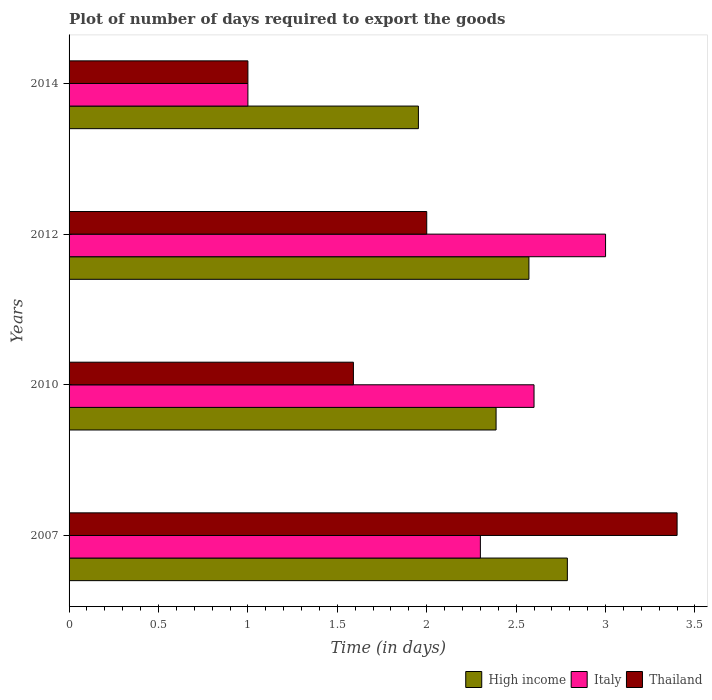How many different coloured bars are there?
Make the answer very short. 3. How many groups of bars are there?
Ensure brevity in your answer.  4. Are the number of bars on each tick of the Y-axis equal?
Provide a short and direct response. Yes. What is the label of the 3rd group of bars from the top?
Give a very brief answer. 2010. In how many cases, is the number of bars for a given year not equal to the number of legend labels?
Your response must be concise. 0. What is the time required to export goods in Thailand in 2014?
Offer a terse response. 1. Across all years, what is the maximum time required to export goods in Thailand?
Give a very brief answer. 3.4. Across all years, what is the minimum time required to export goods in Thailand?
Offer a very short reply. 1. In which year was the time required to export goods in Thailand maximum?
Give a very brief answer. 2007. What is the difference between the time required to export goods in Thailand in 2010 and that in 2012?
Provide a short and direct response. -0.41. What is the difference between the time required to export goods in Italy in 2014 and the time required to export goods in Thailand in 2012?
Your response must be concise. -1. What is the average time required to export goods in High income per year?
Ensure brevity in your answer.  2.42. In the year 2007, what is the difference between the time required to export goods in High income and time required to export goods in Italy?
Offer a terse response. 0.49. What is the ratio of the time required to export goods in Thailand in 2007 to that in 2014?
Give a very brief answer. 3.4. What is the difference between the highest and the second highest time required to export goods in High income?
Ensure brevity in your answer.  0.21. In how many years, is the time required to export goods in Italy greater than the average time required to export goods in Italy taken over all years?
Offer a terse response. 3. Is the sum of the time required to export goods in Italy in 2010 and 2012 greater than the maximum time required to export goods in Thailand across all years?
Ensure brevity in your answer.  Yes. What does the 1st bar from the bottom in 2010 represents?
Provide a short and direct response. High income. Is it the case that in every year, the sum of the time required to export goods in High income and time required to export goods in Italy is greater than the time required to export goods in Thailand?
Ensure brevity in your answer.  Yes. How many bars are there?
Offer a very short reply. 12. What is the difference between two consecutive major ticks on the X-axis?
Make the answer very short. 0.5. Does the graph contain grids?
Provide a short and direct response. No. How many legend labels are there?
Provide a short and direct response. 3. What is the title of the graph?
Your response must be concise. Plot of number of days required to export the goods. What is the label or title of the X-axis?
Provide a succinct answer. Time (in days). What is the Time (in days) in High income in 2007?
Give a very brief answer. 2.79. What is the Time (in days) of Italy in 2007?
Make the answer very short. 2.3. What is the Time (in days) of Thailand in 2007?
Offer a very short reply. 3.4. What is the Time (in days) of High income in 2010?
Your response must be concise. 2.39. What is the Time (in days) of Italy in 2010?
Your answer should be very brief. 2.6. What is the Time (in days) in Thailand in 2010?
Your answer should be compact. 1.59. What is the Time (in days) of High income in 2012?
Offer a very short reply. 2.57. What is the Time (in days) of Italy in 2012?
Provide a succinct answer. 3. What is the Time (in days) in High income in 2014?
Ensure brevity in your answer.  1.95. What is the Time (in days) of Italy in 2014?
Offer a terse response. 1. What is the Time (in days) of Thailand in 2014?
Provide a succinct answer. 1. Across all years, what is the maximum Time (in days) of High income?
Make the answer very short. 2.79. Across all years, what is the maximum Time (in days) of Italy?
Provide a short and direct response. 3. Across all years, what is the minimum Time (in days) of High income?
Offer a terse response. 1.95. What is the total Time (in days) in High income in the graph?
Offer a very short reply. 9.7. What is the total Time (in days) in Thailand in the graph?
Make the answer very short. 7.99. What is the difference between the Time (in days) in High income in 2007 and that in 2010?
Offer a terse response. 0.4. What is the difference between the Time (in days) in Thailand in 2007 and that in 2010?
Offer a terse response. 1.81. What is the difference between the Time (in days) in High income in 2007 and that in 2012?
Offer a terse response. 0.21. What is the difference between the Time (in days) in Italy in 2007 and that in 2012?
Give a very brief answer. -0.7. What is the difference between the Time (in days) in Thailand in 2007 and that in 2012?
Your response must be concise. 1.4. What is the difference between the Time (in days) of High income in 2007 and that in 2014?
Ensure brevity in your answer.  0.83. What is the difference between the Time (in days) in High income in 2010 and that in 2012?
Ensure brevity in your answer.  -0.18. What is the difference between the Time (in days) of Italy in 2010 and that in 2012?
Give a very brief answer. -0.4. What is the difference between the Time (in days) of Thailand in 2010 and that in 2012?
Keep it short and to the point. -0.41. What is the difference between the Time (in days) in High income in 2010 and that in 2014?
Provide a succinct answer. 0.43. What is the difference between the Time (in days) in Italy in 2010 and that in 2014?
Give a very brief answer. 1.6. What is the difference between the Time (in days) of Thailand in 2010 and that in 2014?
Ensure brevity in your answer.  0.59. What is the difference between the Time (in days) in High income in 2012 and that in 2014?
Keep it short and to the point. 0.62. What is the difference between the Time (in days) in Italy in 2012 and that in 2014?
Give a very brief answer. 2. What is the difference between the Time (in days) of Thailand in 2012 and that in 2014?
Your response must be concise. 1. What is the difference between the Time (in days) of High income in 2007 and the Time (in days) of Italy in 2010?
Keep it short and to the point. 0.19. What is the difference between the Time (in days) of High income in 2007 and the Time (in days) of Thailand in 2010?
Offer a very short reply. 1.2. What is the difference between the Time (in days) of Italy in 2007 and the Time (in days) of Thailand in 2010?
Ensure brevity in your answer.  0.71. What is the difference between the Time (in days) of High income in 2007 and the Time (in days) of Italy in 2012?
Keep it short and to the point. -0.21. What is the difference between the Time (in days) in High income in 2007 and the Time (in days) in Thailand in 2012?
Give a very brief answer. 0.79. What is the difference between the Time (in days) of High income in 2007 and the Time (in days) of Italy in 2014?
Your response must be concise. 1.79. What is the difference between the Time (in days) in High income in 2007 and the Time (in days) in Thailand in 2014?
Ensure brevity in your answer.  1.79. What is the difference between the Time (in days) of Italy in 2007 and the Time (in days) of Thailand in 2014?
Offer a terse response. 1.3. What is the difference between the Time (in days) in High income in 2010 and the Time (in days) in Italy in 2012?
Give a very brief answer. -0.61. What is the difference between the Time (in days) in High income in 2010 and the Time (in days) in Thailand in 2012?
Give a very brief answer. 0.39. What is the difference between the Time (in days) in High income in 2010 and the Time (in days) in Italy in 2014?
Your response must be concise. 1.39. What is the difference between the Time (in days) in High income in 2010 and the Time (in days) in Thailand in 2014?
Provide a short and direct response. 1.39. What is the difference between the Time (in days) of High income in 2012 and the Time (in days) of Italy in 2014?
Make the answer very short. 1.57. What is the difference between the Time (in days) of High income in 2012 and the Time (in days) of Thailand in 2014?
Offer a terse response. 1.57. What is the difference between the Time (in days) of Italy in 2012 and the Time (in days) of Thailand in 2014?
Your response must be concise. 2. What is the average Time (in days) in High income per year?
Your answer should be very brief. 2.42. What is the average Time (in days) of Italy per year?
Keep it short and to the point. 2.23. What is the average Time (in days) in Thailand per year?
Provide a succinct answer. 2. In the year 2007, what is the difference between the Time (in days) in High income and Time (in days) in Italy?
Your answer should be very brief. 0.49. In the year 2007, what is the difference between the Time (in days) of High income and Time (in days) of Thailand?
Your answer should be very brief. -0.61. In the year 2007, what is the difference between the Time (in days) in Italy and Time (in days) in Thailand?
Ensure brevity in your answer.  -1.1. In the year 2010, what is the difference between the Time (in days) in High income and Time (in days) in Italy?
Your answer should be very brief. -0.21. In the year 2010, what is the difference between the Time (in days) in High income and Time (in days) in Thailand?
Offer a very short reply. 0.8. In the year 2010, what is the difference between the Time (in days) in Italy and Time (in days) in Thailand?
Provide a short and direct response. 1.01. In the year 2012, what is the difference between the Time (in days) in High income and Time (in days) in Italy?
Your response must be concise. -0.43. In the year 2014, what is the difference between the Time (in days) in High income and Time (in days) in Italy?
Your answer should be very brief. 0.95. In the year 2014, what is the difference between the Time (in days) in High income and Time (in days) in Thailand?
Your response must be concise. 0.95. What is the ratio of the Time (in days) of High income in 2007 to that in 2010?
Your response must be concise. 1.17. What is the ratio of the Time (in days) in Italy in 2007 to that in 2010?
Your answer should be compact. 0.88. What is the ratio of the Time (in days) of Thailand in 2007 to that in 2010?
Offer a terse response. 2.14. What is the ratio of the Time (in days) of High income in 2007 to that in 2012?
Provide a succinct answer. 1.08. What is the ratio of the Time (in days) in Italy in 2007 to that in 2012?
Your response must be concise. 0.77. What is the ratio of the Time (in days) in High income in 2007 to that in 2014?
Provide a succinct answer. 1.43. What is the ratio of the Time (in days) of Italy in 2007 to that in 2014?
Give a very brief answer. 2.3. What is the ratio of the Time (in days) of Thailand in 2007 to that in 2014?
Provide a succinct answer. 3.4. What is the ratio of the Time (in days) in High income in 2010 to that in 2012?
Provide a succinct answer. 0.93. What is the ratio of the Time (in days) of Italy in 2010 to that in 2012?
Give a very brief answer. 0.87. What is the ratio of the Time (in days) of Thailand in 2010 to that in 2012?
Your response must be concise. 0.8. What is the ratio of the Time (in days) of High income in 2010 to that in 2014?
Your response must be concise. 1.22. What is the ratio of the Time (in days) in Thailand in 2010 to that in 2014?
Make the answer very short. 1.59. What is the ratio of the Time (in days) in High income in 2012 to that in 2014?
Your response must be concise. 1.32. What is the ratio of the Time (in days) of Italy in 2012 to that in 2014?
Ensure brevity in your answer.  3. What is the difference between the highest and the second highest Time (in days) in High income?
Your answer should be very brief. 0.21. What is the difference between the highest and the lowest Time (in days) of High income?
Offer a very short reply. 0.83. What is the difference between the highest and the lowest Time (in days) of Thailand?
Offer a very short reply. 2.4. 